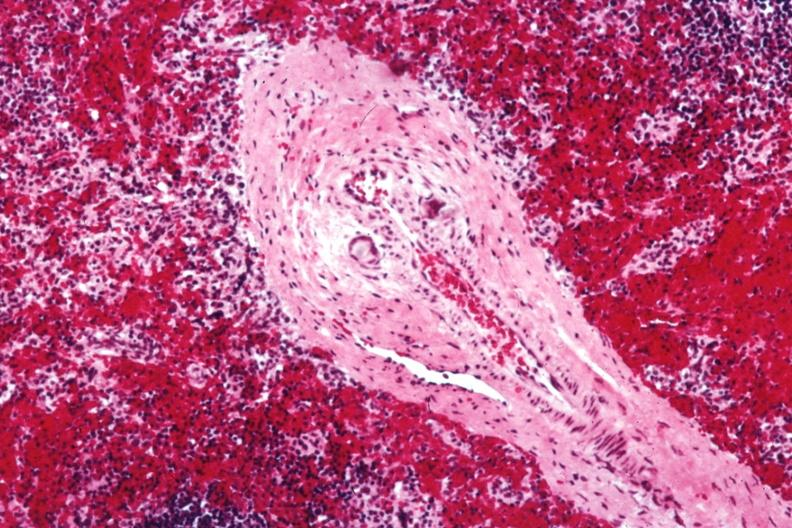how does this image show med artery?
Answer the question using a single word or phrase. With giant cells in wall containing crystalline material postoperative cardiac surgery thought to be silicon 